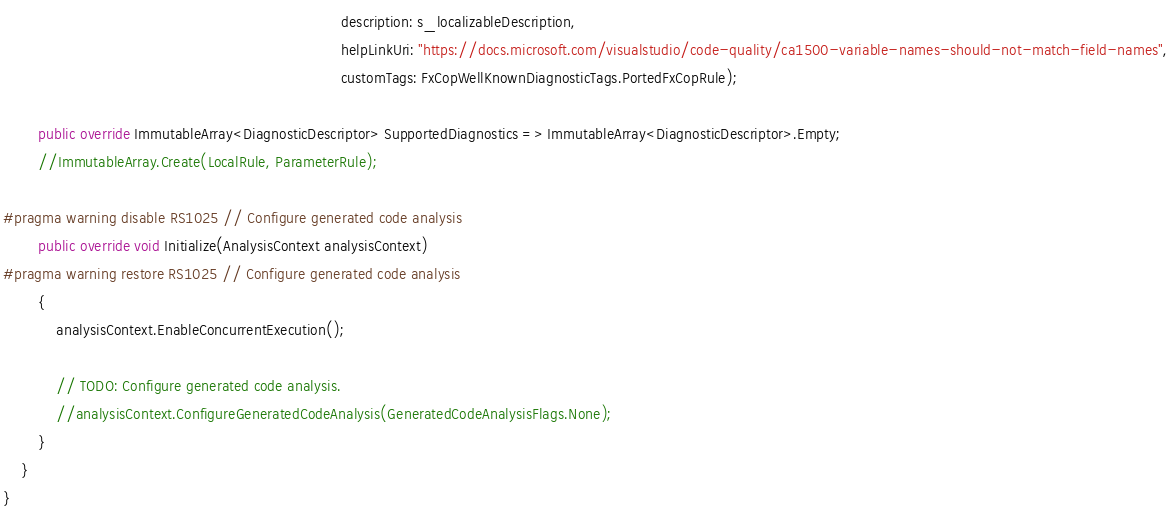<code> <loc_0><loc_0><loc_500><loc_500><_C#_>                                                                             description: s_localizableDescription,
                                                                             helpLinkUri: "https://docs.microsoft.com/visualstudio/code-quality/ca1500-variable-names-should-not-match-field-names",
                                                                             customTags: FxCopWellKnownDiagnosticTags.PortedFxCopRule);

        public override ImmutableArray<DiagnosticDescriptor> SupportedDiagnostics => ImmutableArray<DiagnosticDescriptor>.Empty;
        //ImmutableArray.Create(LocalRule, ParameterRule);

#pragma warning disable RS1025 // Configure generated code analysis
        public override void Initialize(AnalysisContext analysisContext)
#pragma warning restore RS1025 // Configure generated code analysis
        {
            analysisContext.EnableConcurrentExecution();

            // TODO: Configure generated code analysis.
            //analysisContext.ConfigureGeneratedCodeAnalysis(GeneratedCodeAnalysisFlags.None);
        }
    }
}</code> 